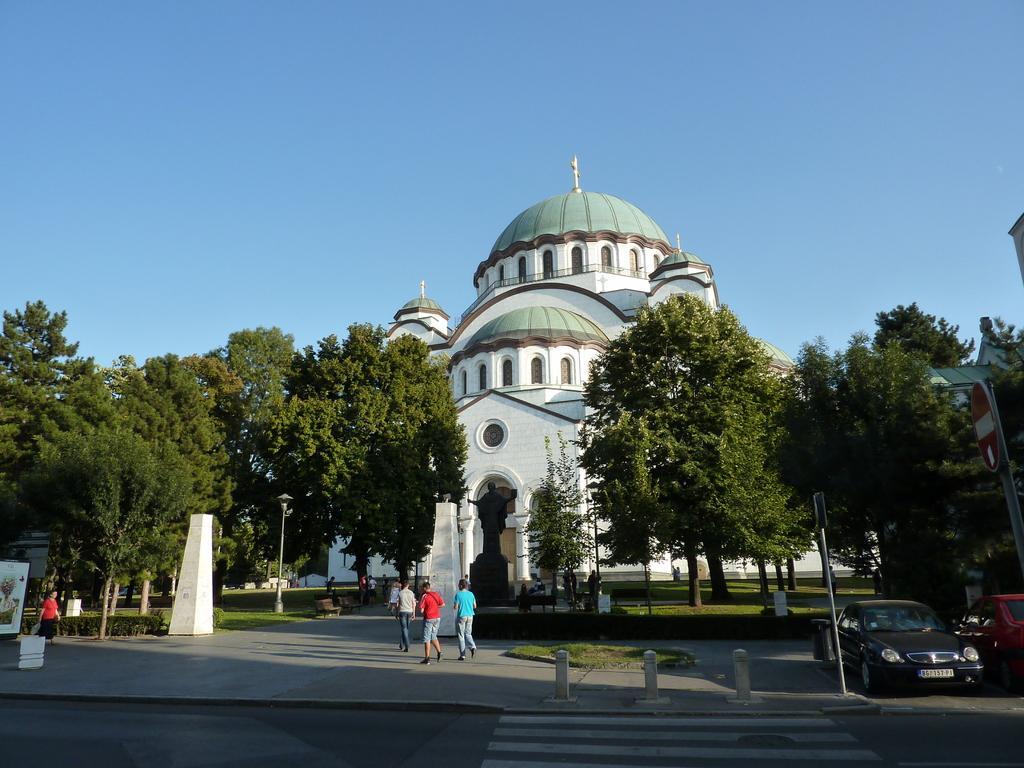Please provide a concise description of this image. In this picture I can see a building and around there are some trees, plants, people and some cars. 